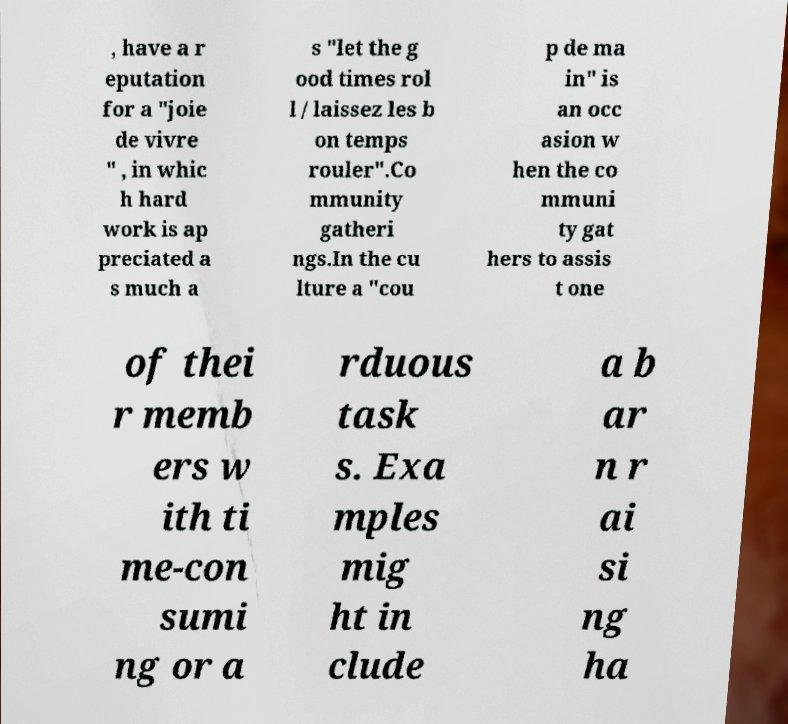There's text embedded in this image that I need extracted. Can you transcribe it verbatim? , have a r eputation for a "joie de vivre " , in whic h hard work is ap preciated a s much a s "let the g ood times rol l / laissez les b on temps rouler".Co mmunity gatheri ngs.In the cu lture a "cou p de ma in" is an occ asion w hen the co mmuni ty gat hers to assis t one of thei r memb ers w ith ti me-con sumi ng or a rduous task s. Exa mples mig ht in clude a b ar n r ai si ng ha 